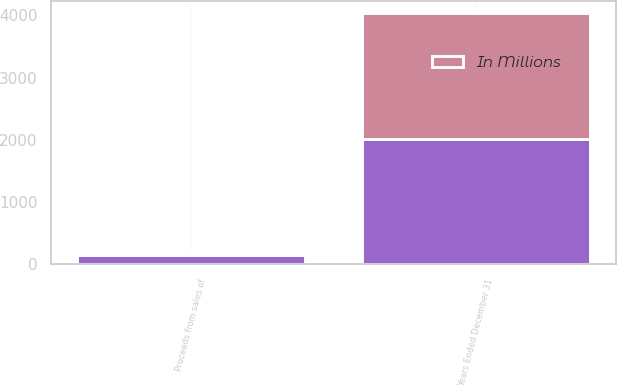<chart> <loc_0><loc_0><loc_500><loc_500><stacked_bar_chart><ecel><fcel>Years Ended December 31<fcel>Proceeds from sales of<nl><fcel>nan<fcel>2017<fcel>145<nl><fcel>In Millions<fcel>2016<fcel>6<nl></chart> 